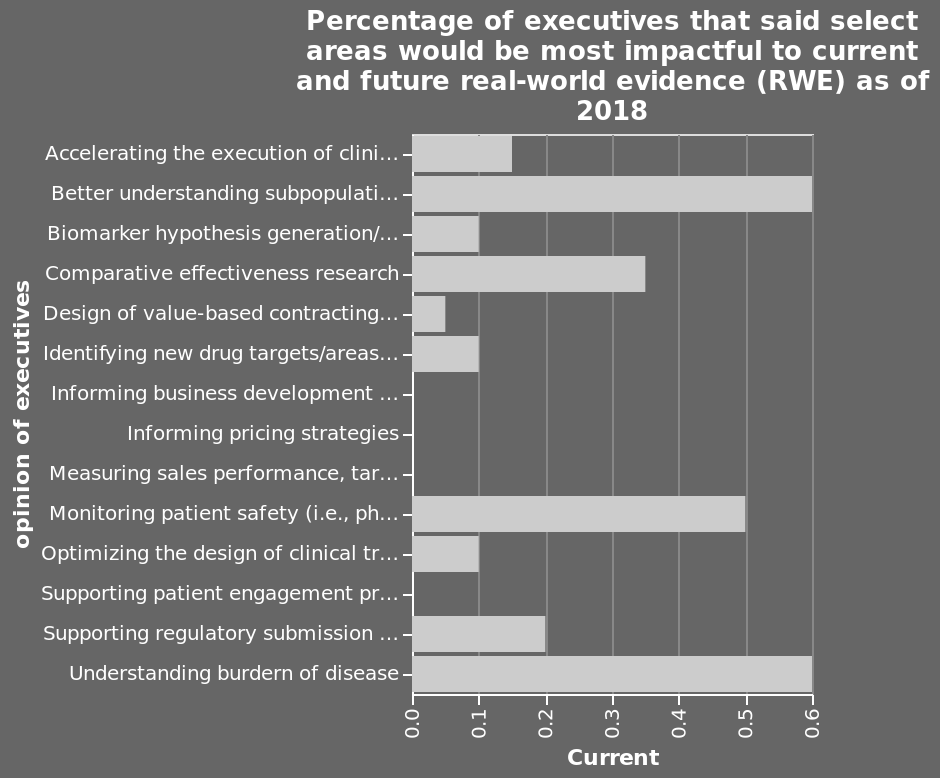<image>
What does the x-axis of the bar graph represent?  The x-axis represents the current scale ranging from 0.0 to 0.6. please summary the statistics and relations of the chart Understanding burden of disease and better understanding of subpopulation are the most popular categories by executives. What is the name of the bar graph mentioned in the figure? The bar graph is named "Percentage of executives that said select areas would be most impactful to current and future real-world evidence (RWE) as of 2018." Why are executives interested in better understanding subpopulation? Executives are interested in better understanding subpopulation because it aids in identifying specific needs and tailoring solutions accordingly. What does the y-axis of the bar graph represent?  The y-axis represents the opinion of executives on a categorical scale ranging from Accelerating the execution of clinical trials using RWD as a control arm for clinical trials to Understanding burden of disease. 